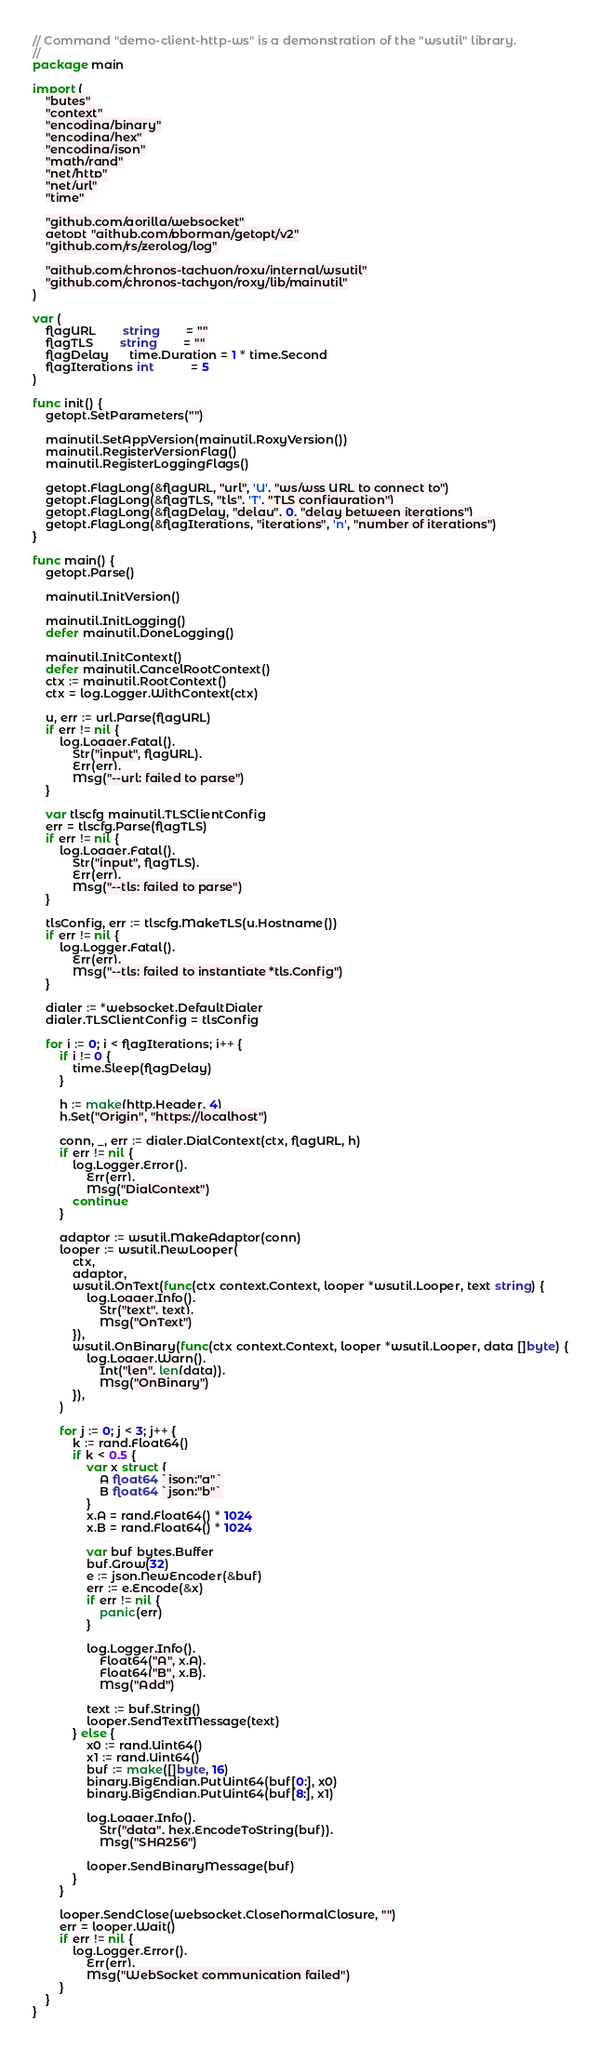Convert code to text. <code><loc_0><loc_0><loc_500><loc_500><_Go_>// Command "demo-client-http-ws" is a demonstration of the "wsutil" library.
//
package main

import (
	"bytes"
	"context"
	"encoding/binary"
	"encoding/hex"
	"encoding/json"
	"math/rand"
	"net/http"
	"net/url"
	"time"

	"github.com/gorilla/websocket"
	getopt "github.com/pborman/getopt/v2"
	"github.com/rs/zerolog/log"

	"github.com/chronos-tachyon/roxy/internal/wsutil"
	"github.com/chronos-tachyon/roxy/lib/mainutil"
)

var (
	flagURL        string        = ""
	flagTLS        string        = ""
	flagDelay      time.Duration = 1 * time.Second
	flagIterations int           = 5
)

func init() {
	getopt.SetParameters("")

	mainutil.SetAppVersion(mainutil.RoxyVersion())
	mainutil.RegisterVersionFlag()
	mainutil.RegisterLoggingFlags()

	getopt.FlagLong(&flagURL, "url", 'U', "ws/wss URL to connect to")
	getopt.FlagLong(&flagTLS, "tls", 'T', "TLS configuration")
	getopt.FlagLong(&flagDelay, "delay", 0, "delay between iterations")
	getopt.FlagLong(&flagIterations, "iterations", 'n', "number of iterations")
}

func main() {
	getopt.Parse()

	mainutil.InitVersion()

	mainutil.InitLogging()
	defer mainutil.DoneLogging()

	mainutil.InitContext()
	defer mainutil.CancelRootContext()
	ctx := mainutil.RootContext()
	ctx = log.Logger.WithContext(ctx)

	u, err := url.Parse(flagURL)
	if err != nil {
		log.Logger.Fatal().
			Str("input", flagURL).
			Err(err).
			Msg("--url: failed to parse")
	}

	var tlscfg mainutil.TLSClientConfig
	err = tlscfg.Parse(flagTLS)
	if err != nil {
		log.Logger.Fatal().
			Str("input", flagTLS).
			Err(err).
			Msg("--tls: failed to parse")
	}

	tlsConfig, err := tlscfg.MakeTLS(u.Hostname())
	if err != nil {
		log.Logger.Fatal().
			Err(err).
			Msg("--tls: failed to instantiate *tls.Config")
	}

	dialer := *websocket.DefaultDialer
	dialer.TLSClientConfig = tlsConfig

	for i := 0; i < flagIterations; i++ {
		if i != 0 {
			time.Sleep(flagDelay)
		}

		h := make(http.Header, 4)
		h.Set("Origin", "https://localhost")

		conn, _, err := dialer.DialContext(ctx, flagURL, h)
		if err != nil {
			log.Logger.Error().
				Err(err).
				Msg("DialContext")
			continue
		}

		adaptor := wsutil.MakeAdaptor(conn)
		looper := wsutil.NewLooper(
			ctx,
			adaptor,
			wsutil.OnText(func(ctx context.Context, looper *wsutil.Looper, text string) {
				log.Logger.Info().
					Str("text", text).
					Msg("OnText")
			}),
			wsutil.OnBinary(func(ctx context.Context, looper *wsutil.Looper, data []byte) {
				log.Logger.Warn().
					Int("len", len(data)).
					Msg("OnBinary")
			}),
		)

		for j := 0; j < 3; j++ {
			k := rand.Float64()
			if k < 0.5 {
				var x struct {
					A float64 `json:"a"`
					B float64 `json:"b"`
				}
				x.A = rand.Float64() * 1024
				x.B = rand.Float64() * 1024

				var buf bytes.Buffer
				buf.Grow(32)
				e := json.NewEncoder(&buf)
				err := e.Encode(&x)
				if err != nil {
					panic(err)
				}

				log.Logger.Info().
					Float64("A", x.A).
					Float64("B", x.B).
					Msg("Add")

				text := buf.String()
				looper.SendTextMessage(text)
			} else {
				x0 := rand.Uint64()
				x1 := rand.Uint64()
				buf := make([]byte, 16)
				binary.BigEndian.PutUint64(buf[0:], x0)
				binary.BigEndian.PutUint64(buf[8:], x1)

				log.Logger.Info().
					Str("data", hex.EncodeToString(buf)).
					Msg("SHA256")

				looper.SendBinaryMessage(buf)
			}
		}

		looper.SendClose(websocket.CloseNormalClosure, "")
		err = looper.Wait()
		if err != nil {
			log.Logger.Error().
				Err(err).
				Msg("WebSocket communication failed")
		}
	}
}
</code> 